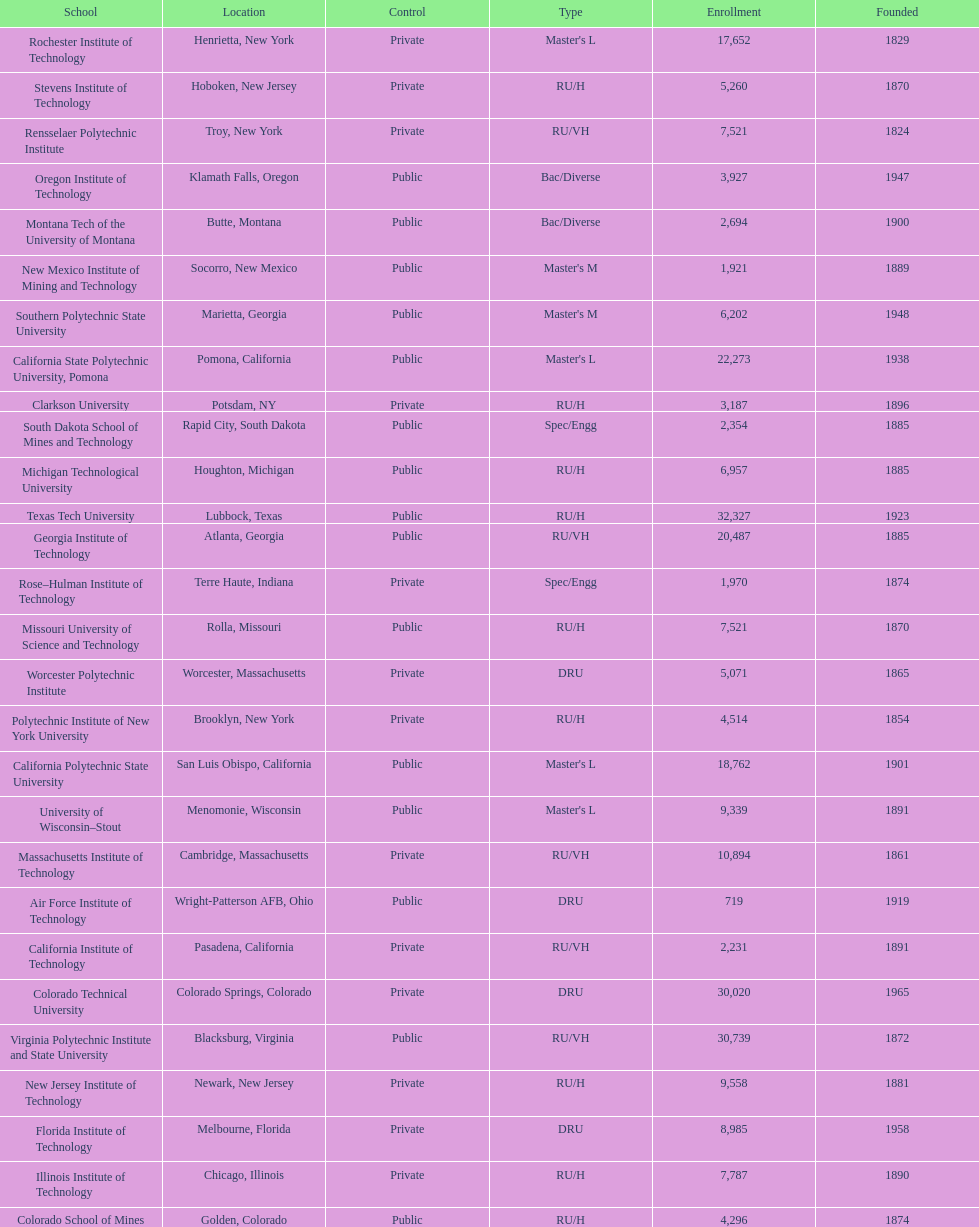Which us technological university has the top enrollment numbers? Texas Tech University. 